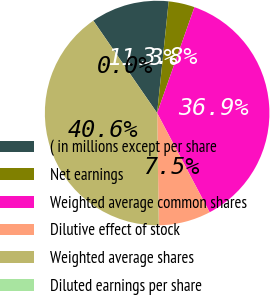<chart> <loc_0><loc_0><loc_500><loc_500><pie_chart><fcel>( in millions except per share<fcel>Net earnings<fcel>Weighted average common shares<fcel>Dilutive effect of stock<fcel>Weighted average shares<fcel>Diluted earnings per share<nl><fcel>11.26%<fcel>3.75%<fcel>36.86%<fcel>7.51%<fcel>40.61%<fcel>0.0%<nl></chart> 